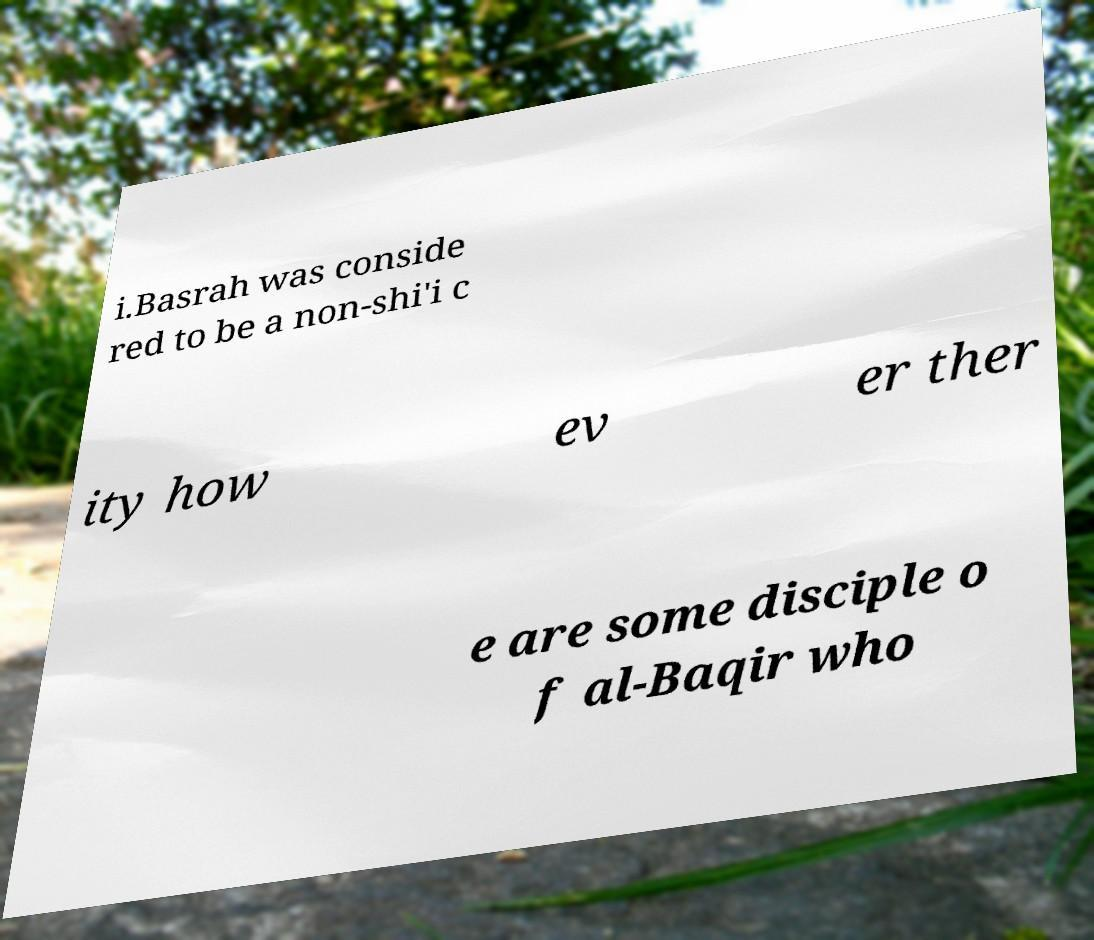Can you accurately transcribe the text from the provided image for me? i.Basrah was conside red to be a non-shi'i c ity how ev er ther e are some disciple o f al-Baqir who 